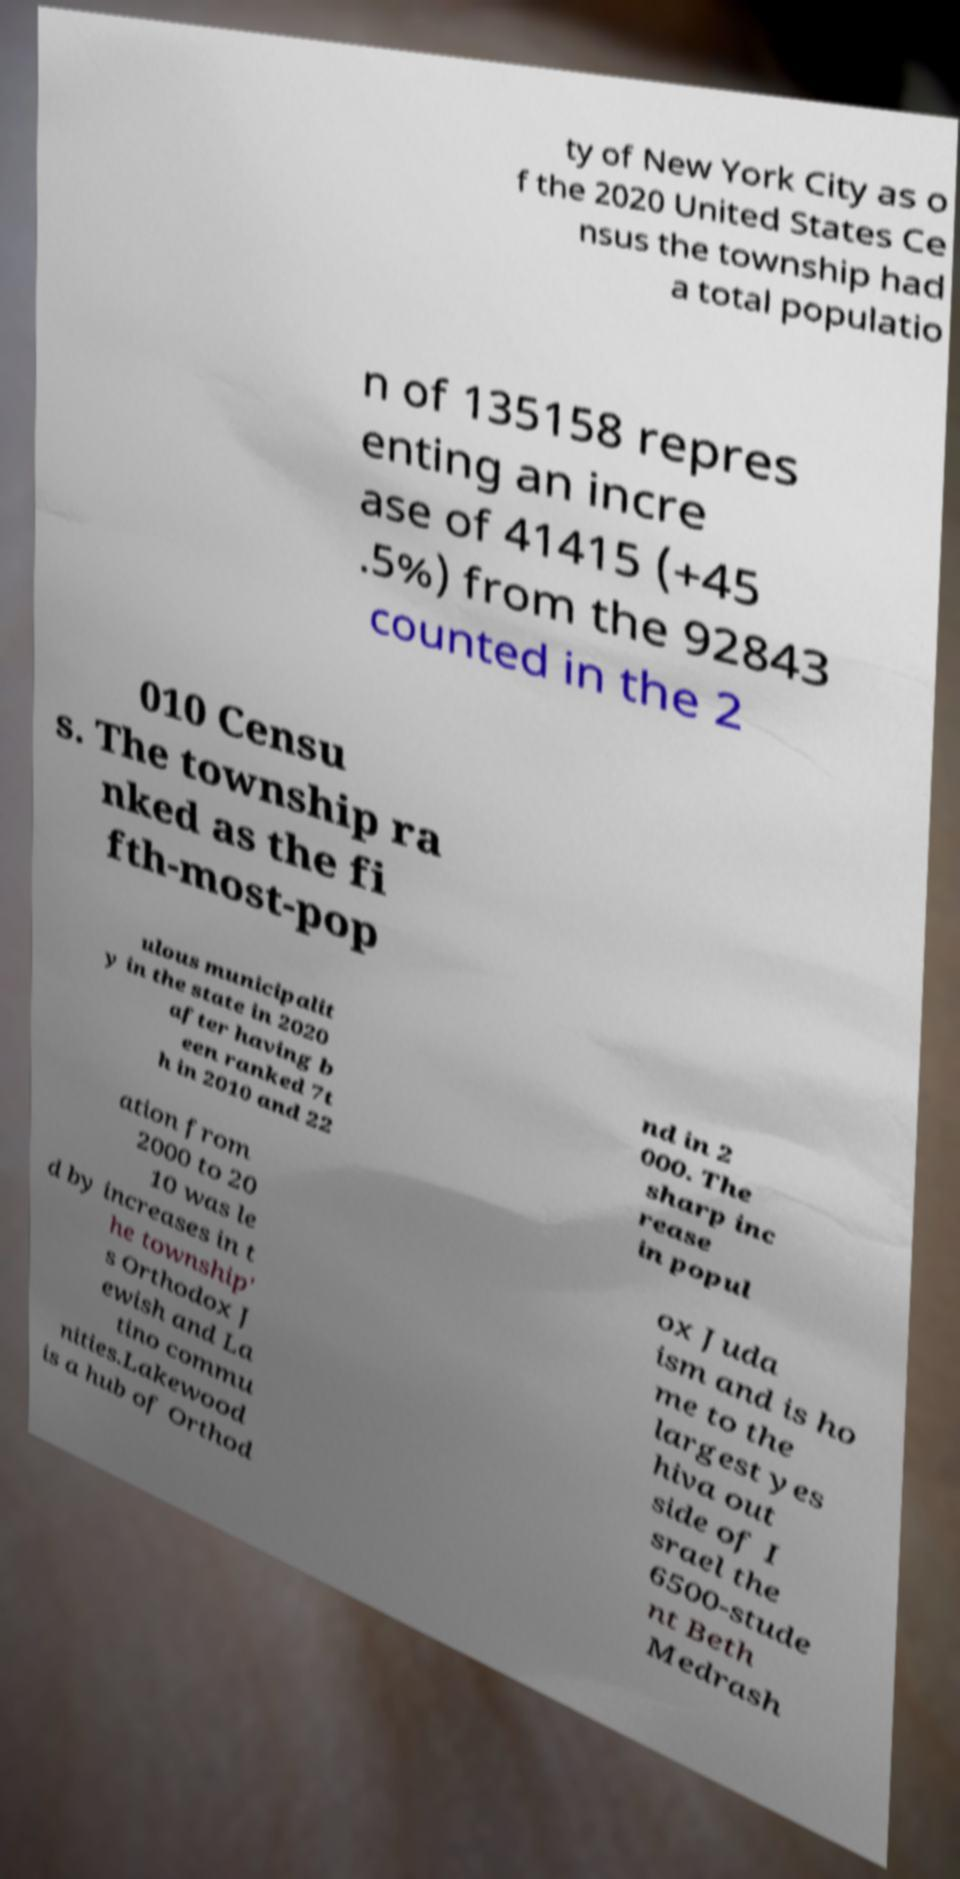Please read and relay the text visible in this image. What does it say? ty of New York City as o f the 2020 United States Ce nsus the township had a total populatio n of 135158 repres enting an incre ase of 41415 (+45 .5%) from the 92843 counted in the 2 010 Censu s. The township ra nked as the fi fth-most-pop ulous municipalit y in the state in 2020 after having b een ranked 7t h in 2010 and 22 nd in 2 000. The sharp inc rease in popul ation from 2000 to 20 10 was le d by increases in t he township' s Orthodox J ewish and La tino commu nities.Lakewood is a hub of Orthod ox Juda ism and is ho me to the largest yes hiva out side of I srael the 6500-stude nt Beth Medrash 